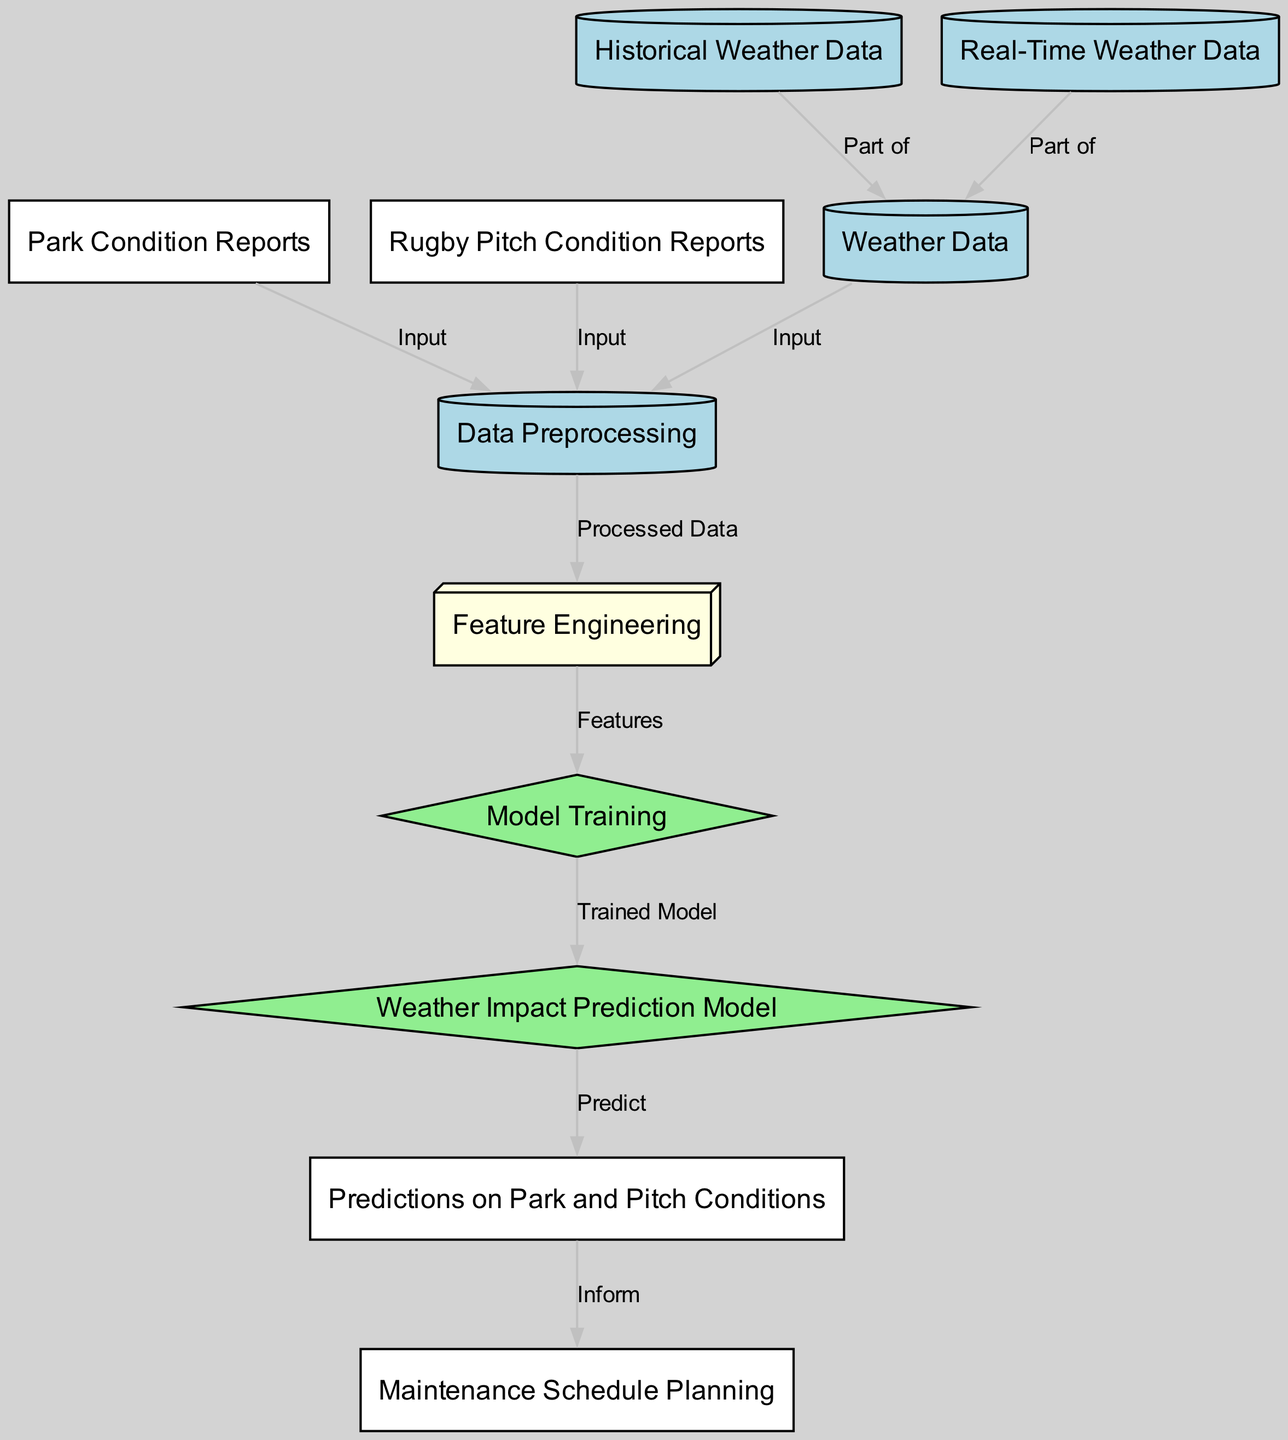What is the main data input for the model? The model primarily receives input from the weather data node, which encompasses both historical and real-time weather data. This is clearly indicated by the outgoing edge from the weather data node to the data preprocessing node.
Answer: Weather Data How many nodes are there in total? By counting the nodes listed in the diagram, we find there are 11 distinct nodes that represent various elements of the weather impact prediction process.
Answer: 11 Which two types of reports are used as input for data preprocessing? The two types of reports that provide input for data preprocessing are park condition reports and rugby pitch condition reports. This can be seen from their respective edges pointing to the data preprocessing node.
Answer: Park Condition Reports and Rugby Pitch Condition Reports What is generated after model training? After the model training process is completed, the output is a trained model, which is depicted as an edge leading to the weather impact model node in the diagram.
Answer: Trained Model How do predictions inform maintenance scheduling? The predictions on park and pitch conditions directly inform the maintenance schedule planning process, as shown by the edge connecting the predictions node to the maintenance schedule node, implying that predictions influence scheduling decisions.
Answer: Inform What is the relationship between historical weather data and real-time weather data? Both historical weather data and real-time weather data are part of the weather data node, agreeing that they contribute to the overall understanding of weather patterns affecting park and pitch conditions. This connection is established through labeled edges indicating they are components of the weather data input.
Answer: Part of What comes after feature engineering in this process? Following the feature engineering stage, the next step is model training, where the engineered features are utilized to train the model, as indicated by the edge that flows from feature engineering to model training.
Answer: Model Training What type of model is developed in this diagram? The model developed in this diagram is referred to as the weather impact prediction model, which emphasizes its role in forecasting the effects of weather on park and rugby pitch conditions. This is represented by the distinct node labeled 'Weather Impact Prediction Model'.
Answer: Weather Impact Prediction Model How does real-time weather data impact the model? Real-time weather data impacts the model by being a crucial part of the overall weather data that inputs into the data preprocessing, thus affecting the model's outputs. The connection is illustrated by the edge from real-time weather data to weather data.
Answer: Part of 